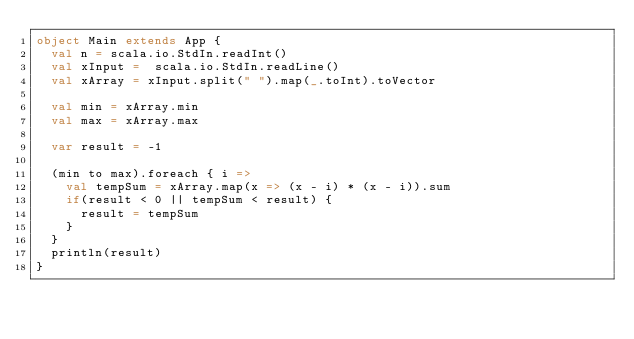Convert code to text. <code><loc_0><loc_0><loc_500><loc_500><_Scala_>object Main extends App {
  val n = scala.io.StdIn.readInt()
  val xInput =  scala.io.StdIn.readLine()
  val xArray = xInput.split(" ").map(_.toInt).toVector

  val min = xArray.min
  val max = xArray.max

  var result = -1

  (min to max).foreach { i =>
    val tempSum = xArray.map(x => (x - i) * (x - i)).sum
    if(result < 0 || tempSum < result) {
      result = tempSum
    }
  }
  println(result)
}</code> 